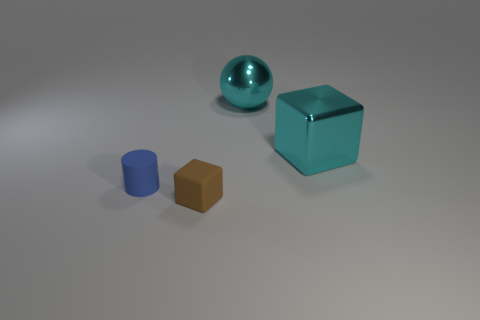Are the objects floating or resting on a surface? The objects appear to be resting on a surface, as there are subtle shadows directly beneath each item suggesting that they are in contact with the ground.  How many objects are there in total? There are three objects visible in the image: a large cyan cube, a smaller blue cylinder, and a similarly smaller brown cube. 